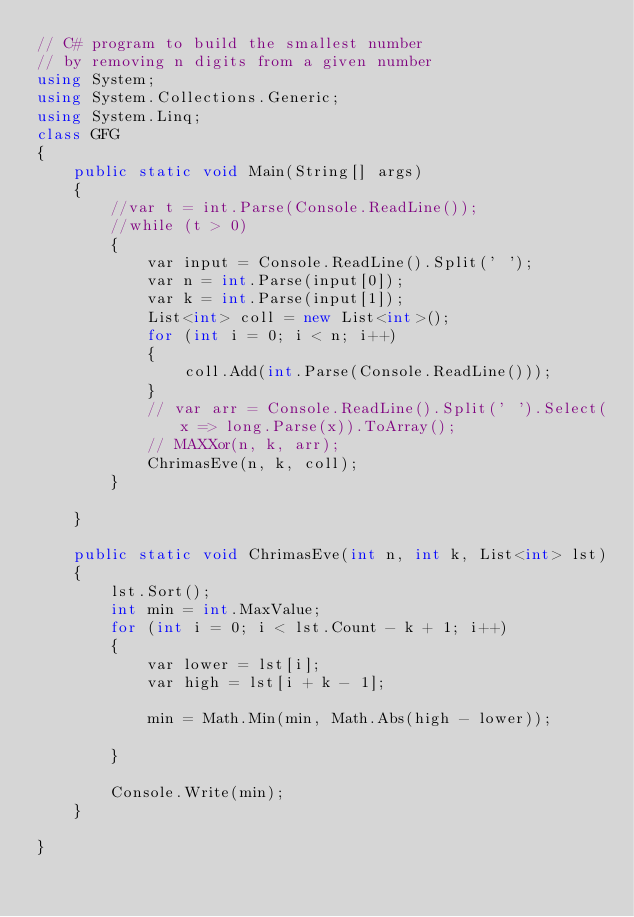<code> <loc_0><loc_0><loc_500><loc_500><_C#_>// C# program to build the smallest number 
// by removing n digits from a given number 
using System;
using System.Collections.Generic;
using System.Linq;
class GFG
{
    public static void Main(String[] args)
    {
        //var t = int.Parse(Console.ReadLine());
        //while (t > 0)
        {
            var input = Console.ReadLine().Split(' ');
            var n = int.Parse(input[0]);
            var k = int.Parse(input[1]);
            List<int> coll = new List<int>();
            for (int i = 0; i < n; i++)
            {
                coll.Add(int.Parse(Console.ReadLine()));
            }
            // var arr = Console.ReadLine().Split(' ').Select(x => long.Parse(x)).ToArray();
            // MAXXor(n, k, arr);
            ChrimasEve(n, k, coll);
        }

    }

    public static void ChrimasEve(int n, int k, List<int> lst)
    {
        lst.Sort();
        int min = int.MaxValue;
        for (int i = 0; i < lst.Count - k + 1; i++)
        {
            var lower = lst[i];
            var high = lst[i + k - 1];

            min = Math.Min(min, Math.Abs(high - lower));

        }

        Console.Write(min);
    }

}

</code> 